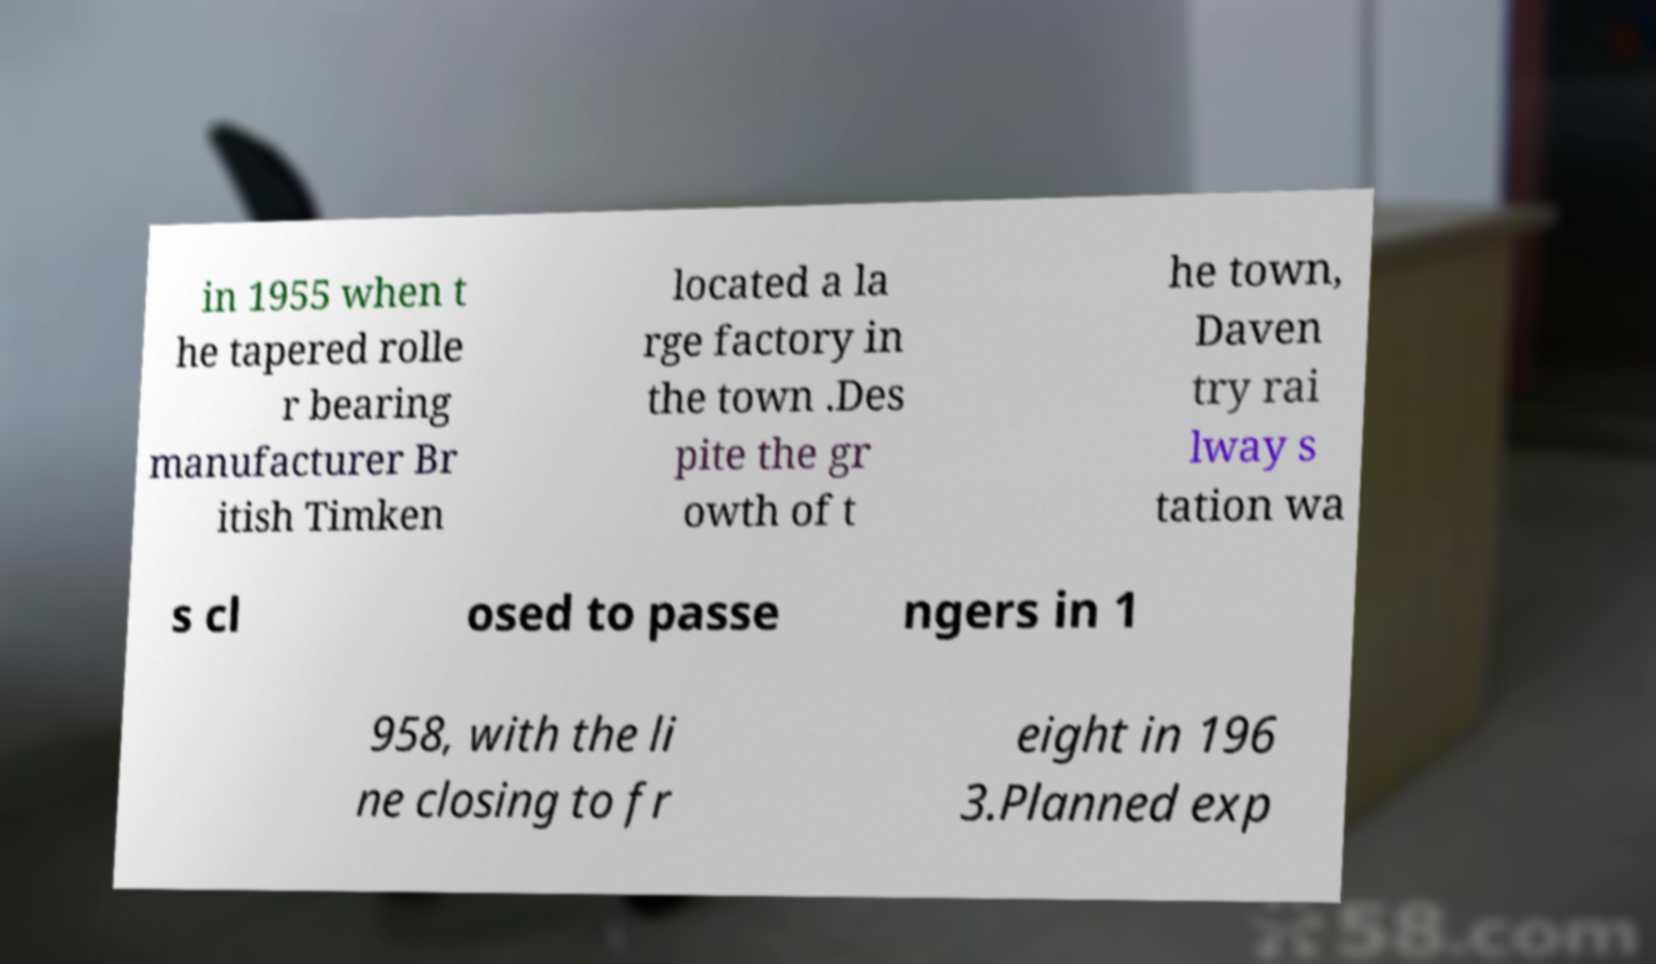Could you assist in decoding the text presented in this image and type it out clearly? in 1955 when t he tapered rolle r bearing manufacturer Br itish Timken located a la rge factory in the town .Des pite the gr owth of t he town, Daven try rai lway s tation wa s cl osed to passe ngers in 1 958, with the li ne closing to fr eight in 196 3.Planned exp 